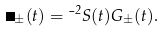<formula> <loc_0><loc_0><loc_500><loc_500>\Sigma _ { \pm } ( t ) = \mu ^ { 2 } S ( t ) G _ { \pm } ( t ) .</formula> 